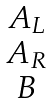Convert formula to latex. <formula><loc_0><loc_0><loc_500><loc_500>\begin{matrix} A _ { L } \\ A _ { R } \\ B \end{matrix}</formula> 